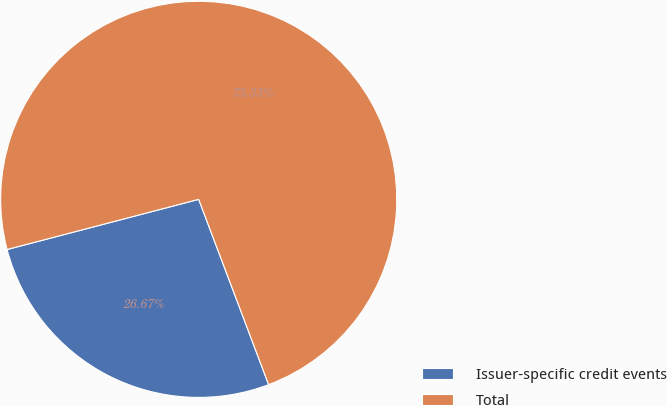Convert chart to OTSL. <chart><loc_0><loc_0><loc_500><loc_500><pie_chart><fcel>Issuer-specific credit events<fcel>Total<nl><fcel>26.67%<fcel>73.33%<nl></chart> 